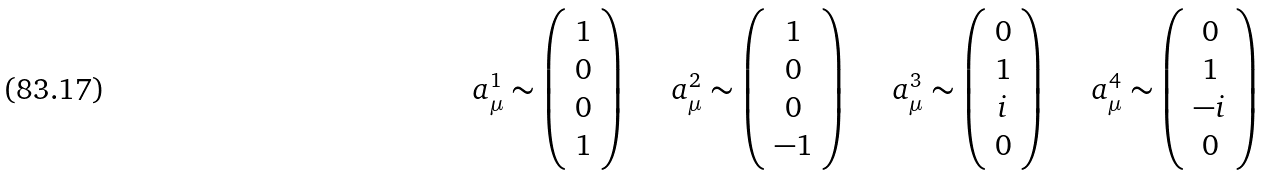Convert formula to latex. <formula><loc_0><loc_0><loc_500><loc_500>\begin{array} { c c c c } a ^ { 1 } _ { \mu } \sim \left ( \begin{array} { c } 1 \\ 0 \\ 0 \\ 1 \end{array} \right ) \quad & a ^ { 2 } _ { \mu } \sim \left ( \begin{array} { c } 1 \\ 0 \\ 0 \\ - 1 \end{array} \right ) \quad & a ^ { 3 } _ { \mu } \sim \left ( \begin{array} { c } 0 \\ 1 \\ i \\ 0 \end{array} \right ) \quad & a ^ { 4 } _ { \mu } \sim \left ( \begin{array} { c } 0 \\ 1 \\ - i \\ 0 \end{array} \right ) \end{array}</formula> 